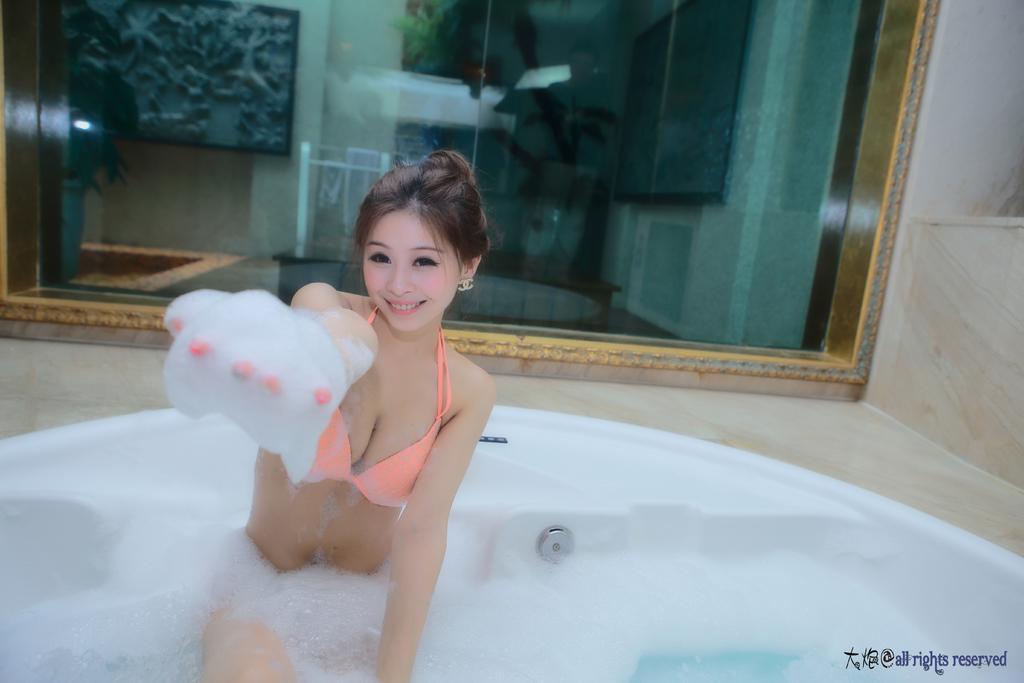Please provide a concise description of this image. In this image there is one woman who is in bathtub, and it seems that she is bathing. And in the background there is a glass window through the window we could see a reflection of photo frame, wall and objects and there is a wall. 